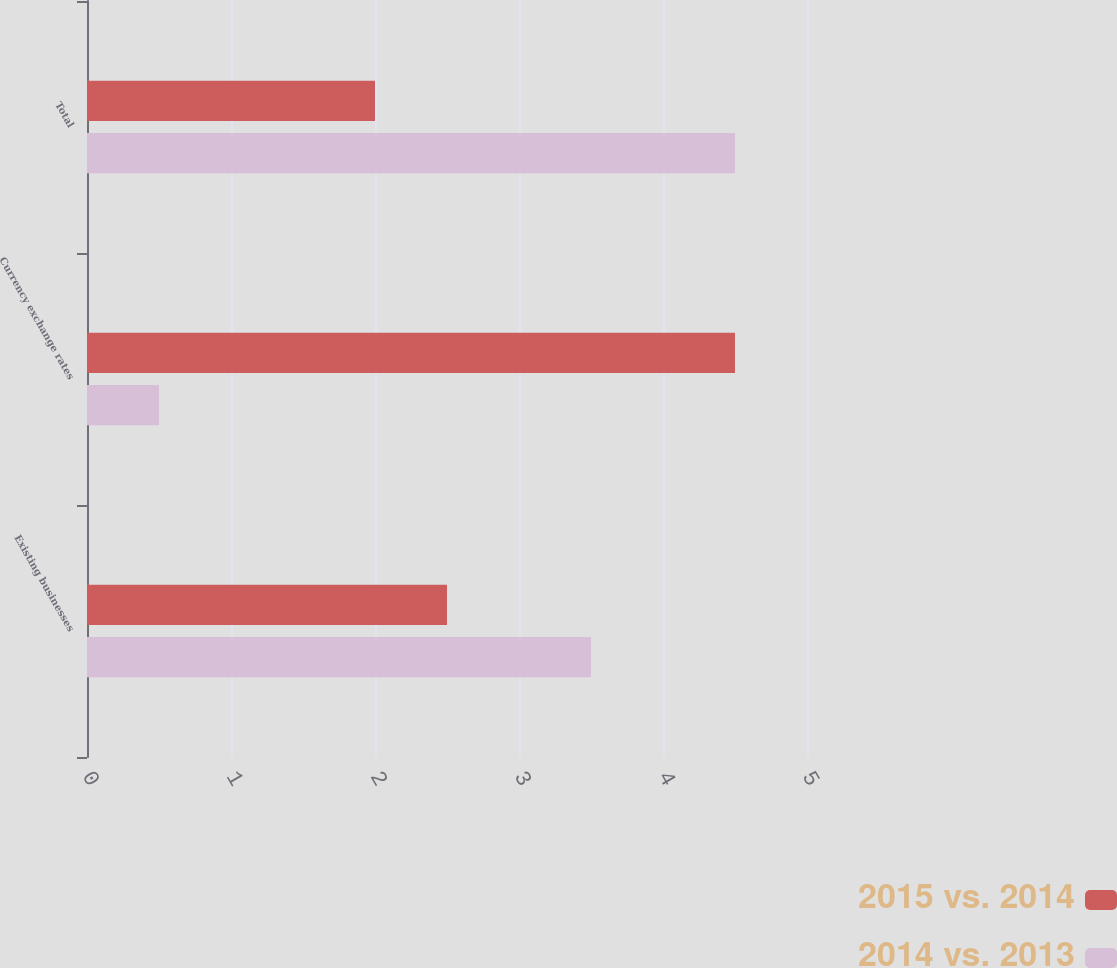<chart> <loc_0><loc_0><loc_500><loc_500><stacked_bar_chart><ecel><fcel>Existing businesses<fcel>Currency exchange rates<fcel>Total<nl><fcel>2015 vs. 2014<fcel>2.5<fcel>4.5<fcel>2<nl><fcel>2014 vs. 2013<fcel>3.5<fcel>0.5<fcel>4.5<nl></chart> 